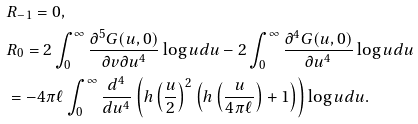Convert formula to latex. <formula><loc_0><loc_0><loc_500><loc_500>& R _ { - 1 } = 0 , \\ & R _ { 0 } = 2 \int _ { 0 } ^ { \infty } \frac { \partial ^ { 5 } G ( u , 0 ) } { \partial v \partial u ^ { 4 } } \log u d u - 2 \int _ { 0 } ^ { \infty } \frac { \partial ^ { 4 } G ( u , 0 ) } { \partial u ^ { 4 } } \log u d u \\ & = - 4 \pi \ell \int _ { 0 } ^ { \infty } \frac { d ^ { 4 } } { d u ^ { 4 } } \left ( h \left ( \frac { u } { 2 } \right ) ^ { 2 } \left ( h \left ( \frac { u } { 4 \pi \ell } \right ) + 1 \right ) \right ) \log u d u .</formula> 